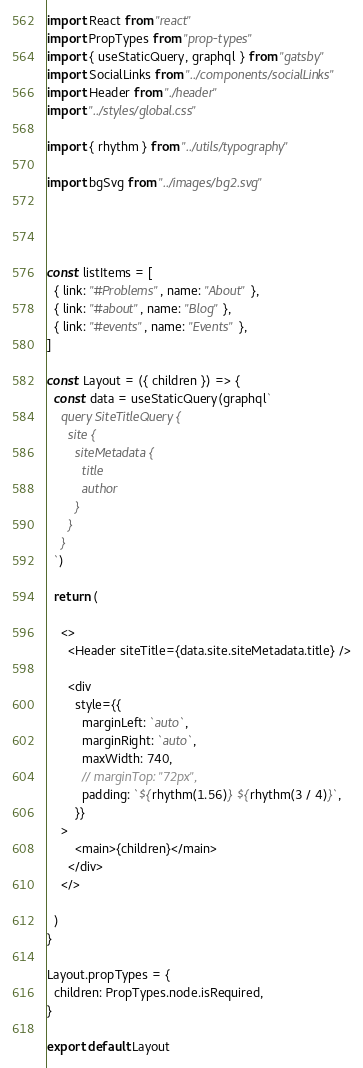Convert code to text. <code><loc_0><loc_0><loc_500><loc_500><_JavaScript_>import React from "react"
import PropTypes from "prop-types"
import { useStaticQuery, graphql } from "gatsby"
import SocialLinks from "../components/socialLinks"
import Header from "./header"
import "../styles/global.css"

import { rhythm } from "../utils/typography"

import bgSvg from "../images/bg2.svg"




const listItems = [
  { link: "#Problems", name: "About" },
  { link: "#about", name: "Blog" },
  { link: "#events", name: "Events" },
]

const Layout = ({ children }) => {
  const data = useStaticQuery(graphql`
    query SiteTitleQuery {
      site {
        siteMetadata {
          title
          author
        }
      }
    }
  `)

  return (
    
    <>
      <Header siteTitle={data.site.siteMetadata.title} />
    
      <div
        style={{
          marginLeft: `auto`,
          marginRight: `auto`,
          maxWidth: 740,
          // marginTop: "72px",
          padding: `${rhythm(1.56)} ${rhythm(3 / 4)}`,
        }}
    >
        <main>{children}</main>
      </div>
    </>
  
  )
}

Layout.propTypes = {
  children: PropTypes.node.isRequired,
}

export default Layout
</code> 